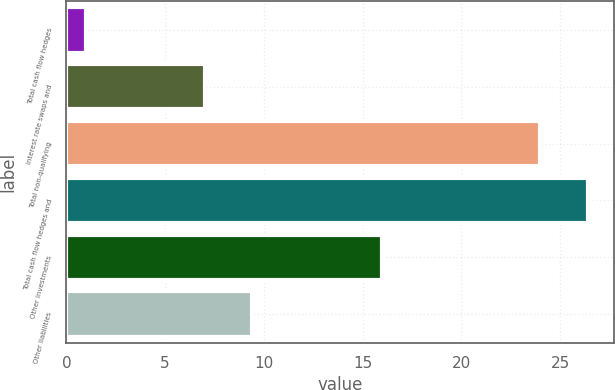<chart> <loc_0><loc_0><loc_500><loc_500><bar_chart><fcel>Total cash flow hedges<fcel>Interest rate swaps and<fcel>Total non-qualifying<fcel>Total cash flow hedges and<fcel>Other investments<fcel>Other liabilities<nl><fcel>1<fcel>7<fcel>24<fcel>26.4<fcel>16<fcel>9.4<nl></chart> 